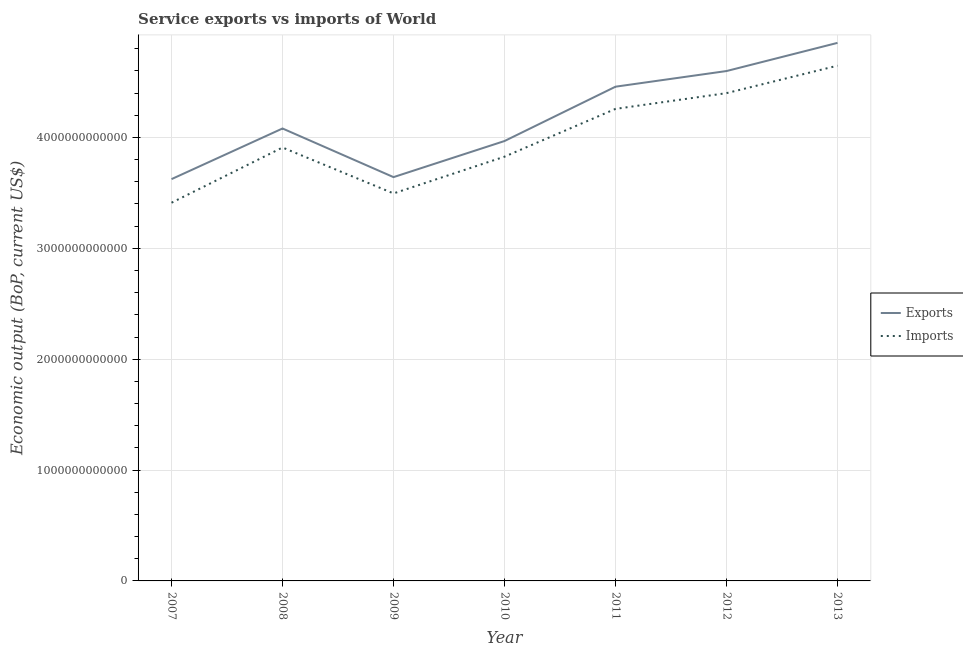How many different coloured lines are there?
Offer a terse response. 2. Does the line corresponding to amount of service imports intersect with the line corresponding to amount of service exports?
Your response must be concise. No. What is the amount of service exports in 2012?
Make the answer very short. 4.60e+12. Across all years, what is the maximum amount of service imports?
Make the answer very short. 4.65e+12. Across all years, what is the minimum amount of service imports?
Provide a short and direct response. 3.41e+12. What is the total amount of service imports in the graph?
Keep it short and to the point. 2.79e+13. What is the difference between the amount of service imports in 2011 and that in 2013?
Provide a succinct answer. -3.90e+11. What is the difference between the amount of service exports in 2011 and the amount of service imports in 2009?
Your answer should be very brief. 9.63e+11. What is the average amount of service exports per year?
Your answer should be compact. 4.18e+12. In the year 2013, what is the difference between the amount of service exports and amount of service imports?
Make the answer very short. 2.06e+11. In how many years, is the amount of service exports greater than 3000000000000 US$?
Offer a terse response. 7. What is the ratio of the amount of service imports in 2008 to that in 2013?
Offer a terse response. 0.84. Is the amount of service exports in 2007 less than that in 2009?
Offer a very short reply. Yes. Is the difference between the amount of service imports in 2007 and 2013 greater than the difference between the amount of service exports in 2007 and 2013?
Offer a very short reply. No. What is the difference between the highest and the second highest amount of service exports?
Give a very brief answer. 2.54e+11. What is the difference between the highest and the lowest amount of service imports?
Give a very brief answer. 1.24e+12. In how many years, is the amount of service imports greater than the average amount of service imports taken over all years?
Give a very brief answer. 3. Does the amount of service exports monotonically increase over the years?
Offer a terse response. No. Is the amount of service imports strictly less than the amount of service exports over the years?
Offer a very short reply. Yes. How many lines are there?
Ensure brevity in your answer.  2. What is the difference between two consecutive major ticks on the Y-axis?
Provide a short and direct response. 1.00e+12. Are the values on the major ticks of Y-axis written in scientific E-notation?
Your response must be concise. No. Does the graph contain grids?
Offer a terse response. Yes. How many legend labels are there?
Keep it short and to the point. 2. How are the legend labels stacked?
Provide a short and direct response. Vertical. What is the title of the graph?
Offer a terse response. Service exports vs imports of World. What is the label or title of the Y-axis?
Keep it short and to the point. Economic output (BoP, current US$). What is the Economic output (BoP, current US$) of Exports in 2007?
Offer a terse response. 3.62e+12. What is the Economic output (BoP, current US$) of Imports in 2007?
Offer a terse response. 3.41e+12. What is the Economic output (BoP, current US$) of Exports in 2008?
Your answer should be very brief. 4.08e+12. What is the Economic output (BoP, current US$) in Imports in 2008?
Your answer should be very brief. 3.91e+12. What is the Economic output (BoP, current US$) of Exports in 2009?
Ensure brevity in your answer.  3.64e+12. What is the Economic output (BoP, current US$) in Imports in 2009?
Your response must be concise. 3.50e+12. What is the Economic output (BoP, current US$) of Exports in 2010?
Make the answer very short. 3.97e+12. What is the Economic output (BoP, current US$) of Imports in 2010?
Your answer should be compact. 3.83e+12. What is the Economic output (BoP, current US$) of Exports in 2011?
Ensure brevity in your answer.  4.46e+12. What is the Economic output (BoP, current US$) in Imports in 2011?
Offer a very short reply. 4.26e+12. What is the Economic output (BoP, current US$) in Exports in 2012?
Your answer should be compact. 4.60e+12. What is the Economic output (BoP, current US$) of Imports in 2012?
Make the answer very short. 4.40e+12. What is the Economic output (BoP, current US$) in Exports in 2013?
Offer a terse response. 4.85e+12. What is the Economic output (BoP, current US$) of Imports in 2013?
Your response must be concise. 4.65e+12. Across all years, what is the maximum Economic output (BoP, current US$) in Exports?
Offer a very short reply. 4.85e+12. Across all years, what is the maximum Economic output (BoP, current US$) in Imports?
Keep it short and to the point. 4.65e+12. Across all years, what is the minimum Economic output (BoP, current US$) of Exports?
Give a very brief answer. 3.62e+12. Across all years, what is the minimum Economic output (BoP, current US$) of Imports?
Make the answer very short. 3.41e+12. What is the total Economic output (BoP, current US$) of Exports in the graph?
Ensure brevity in your answer.  2.92e+13. What is the total Economic output (BoP, current US$) in Imports in the graph?
Ensure brevity in your answer.  2.79e+13. What is the difference between the Economic output (BoP, current US$) of Exports in 2007 and that in 2008?
Ensure brevity in your answer.  -4.57e+11. What is the difference between the Economic output (BoP, current US$) in Imports in 2007 and that in 2008?
Keep it short and to the point. -4.98e+11. What is the difference between the Economic output (BoP, current US$) of Exports in 2007 and that in 2009?
Your answer should be very brief. -1.81e+1. What is the difference between the Economic output (BoP, current US$) in Imports in 2007 and that in 2009?
Provide a short and direct response. -8.39e+1. What is the difference between the Economic output (BoP, current US$) of Exports in 2007 and that in 2010?
Your answer should be very brief. -3.44e+11. What is the difference between the Economic output (BoP, current US$) of Imports in 2007 and that in 2010?
Your answer should be compact. -4.15e+11. What is the difference between the Economic output (BoP, current US$) of Exports in 2007 and that in 2011?
Give a very brief answer. -8.34e+11. What is the difference between the Economic output (BoP, current US$) in Imports in 2007 and that in 2011?
Provide a succinct answer. -8.47e+11. What is the difference between the Economic output (BoP, current US$) of Exports in 2007 and that in 2012?
Keep it short and to the point. -9.75e+11. What is the difference between the Economic output (BoP, current US$) of Imports in 2007 and that in 2012?
Keep it short and to the point. -9.89e+11. What is the difference between the Economic output (BoP, current US$) of Exports in 2007 and that in 2013?
Provide a succinct answer. -1.23e+12. What is the difference between the Economic output (BoP, current US$) of Imports in 2007 and that in 2013?
Provide a succinct answer. -1.24e+12. What is the difference between the Economic output (BoP, current US$) in Exports in 2008 and that in 2009?
Your response must be concise. 4.39e+11. What is the difference between the Economic output (BoP, current US$) in Imports in 2008 and that in 2009?
Make the answer very short. 4.14e+11. What is the difference between the Economic output (BoP, current US$) in Exports in 2008 and that in 2010?
Your answer should be compact. 1.13e+11. What is the difference between the Economic output (BoP, current US$) in Imports in 2008 and that in 2010?
Give a very brief answer. 8.29e+1. What is the difference between the Economic output (BoP, current US$) in Exports in 2008 and that in 2011?
Offer a very short reply. -3.77e+11. What is the difference between the Economic output (BoP, current US$) of Imports in 2008 and that in 2011?
Provide a short and direct response. -3.48e+11. What is the difference between the Economic output (BoP, current US$) of Exports in 2008 and that in 2012?
Offer a very short reply. -5.18e+11. What is the difference between the Economic output (BoP, current US$) of Imports in 2008 and that in 2012?
Your answer should be very brief. -4.90e+11. What is the difference between the Economic output (BoP, current US$) of Exports in 2008 and that in 2013?
Ensure brevity in your answer.  -7.72e+11. What is the difference between the Economic output (BoP, current US$) in Imports in 2008 and that in 2013?
Provide a short and direct response. -7.38e+11. What is the difference between the Economic output (BoP, current US$) of Exports in 2009 and that in 2010?
Ensure brevity in your answer.  -3.26e+11. What is the difference between the Economic output (BoP, current US$) of Imports in 2009 and that in 2010?
Make the answer very short. -3.31e+11. What is the difference between the Economic output (BoP, current US$) in Exports in 2009 and that in 2011?
Ensure brevity in your answer.  -8.16e+11. What is the difference between the Economic output (BoP, current US$) in Imports in 2009 and that in 2011?
Make the answer very short. -7.63e+11. What is the difference between the Economic output (BoP, current US$) in Exports in 2009 and that in 2012?
Your response must be concise. -9.57e+11. What is the difference between the Economic output (BoP, current US$) of Imports in 2009 and that in 2012?
Offer a very short reply. -9.05e+11. What is the difference between the Economic output (BoP, current US$) in Exports in 2009 and that in 2013?
Your answer should be compact. -1.21e+12. What is the difference between the Economic output (BoP, current US$) of Imports in 2009 and that in 2013?
Keep it short and to the point. -1.15e+12. What is the difference between the Economic output (BoP, current US$) in Exports in 2010 and that in 2011?
Your answer should be compact. -4.90e+11. What is the difference between the Economic output (BoP, current US$) in Imports in 2010 and that in 2011?
Provide a short and direct response. -4.31e+11. What is the difference between the Economic output (BoP, current US$) in Exports in 2010 and that in 2012?
Provide a short and direct response. -6.31e+11. What is the difference between the Economic output (BoP, current US$) of Imports in 2010 and that in 2012?
Provide a short and direct response. -5.73e+11. What is the difference between the Economic output (BoP, current US$) of Exports in 2010 and that in 2013?
Provide a short and direct response. -8.85e+11. What is the difference between the Economic output (BoP, current US$) of Imports in 2010 and that in 2013?
Offer a very short reply. -8.21e+11. What is the difference between the Economic output (BoP, current US$) in Exports in 2011 and that in 2012?
Your answer should be very brief. -1.41e+11. What is the difference between the Economic output (BoP, current US$) of Imports in 2011 and that in 2012?
Provide a short and direct response. -1.42e+11. What is the difference between the Economic output (BoP, current US$) in Exports in 2011 and that in 2013?
Make the answer very short. -3.95e+11. What is the difference between the Economic output (BoP, current US$) of Imports in 2011 and that in 2013?
Give a very brief answer. -3.90e+11. What is the difference between the Economic output (BoP, current US$) in Exports in 2012 and that in 2013?
Your response must be concise. -2.54e+11. What is the difference between the Economic output (BoP, current US$) of Imports in 2012 and that in 2013?
Provide a succinct answer. -2.48e+11. What is the difference between the Economic output (BoP, current US$) of Exports in 2007 and the Economic output (BoP, current US$) of Imports in 2008?
Keep it short and to the point. -2.85e+11. What is the difference between the Economic output (BoP, current US$) of Exports in 2007 and the Economic output (BoP, current US$) of Imports in 2009?
Offer a terse response. 1.29e+11. What is the difference between the Economic output (BoP, current US$) in Exports in 2007 and the Economic output (BoP, current US$) in Imports in 2010?
Offer a very short reply. -2.02e+11. What is the difference between the Economic output (BoP, current US$) in Exports in 2007 and the Economic output (BoP, current US$) in Imports in 2011?
Provide a short and direct response. -6.34e+11. What is the difference between the Economic output (BoP, current US$) in Exports in 2007 and the Economic output (BoP, current US$) in Imports in 2012?
Your response must be concise. -7.76e+11. What is the difference between the Economic output (BoP, current US$) in Exports in 2007 and the Economic output (BoP, current US$) in Imports in 2013?
Give a very brief answer. -1.02e+12. What is the difference between the Economic output (BoP, current US$) in Exports in 2008 and the Economic output (BoP, current US$) in Imports in 2009?
Give a very brief answer. 5.86e+11. What is the difference between the Economic output (BoP, current US$) in Exports in 2008 and the Economic output (BoP, current US$) in Imports in 2010?
Offer a very short reply. 2.54e+11. What is the difference between the Economic output (BoP, current US$) in Exports in 2008 and the Economic output (BoP, current US$) in Imports in 2011?
Provide a succinct answer. -1.77e+11. What is the difference between the Economic output (BoP, current US$) in Exports in 2008 and the Economic output (BoP, current US$) in Imports in 2012?
Offer a very short reply. -3.19e+11. What is the difference between the Economic output (BoP, current US$) of Exports in 2008 and the Economic output (BoP, current US$) of Imports in 2013?
Provide a succinct answer. -5.67e+11. What is the difference between the Economic output (BoP, current US$) of Exports in 2009 and the Economic output (BoP, current US$) of Imports in 2010?
Keep it short and to the point. -1.84e+11. What is the difference between the Economic output (BoP, current US$) in Exports in 2009 and the Economic output (BoP, current US$) in Imports in 2011?
Your answer should be very brief. -6.16e+11. What is the difference between the Economic output (BoP, current US$) in Exports in 2009 and the Economic output (BoP, current US$) in Imports in 2012?
Keep it short and to the point. -7.58e+11. What is the difference between the Economic output (BoP, current US$) of Exports in 2009 and the Economic output (BoP, current US$) of Imports in 2013?
Your response must be concise. -1.01e+12. What is the difference between the Economic output (BoP, current US$) of Exports in 2010 and the Economic output (BoP, current US$) of Imports in 2011?
Provide a succinct answer. -2.90e+11. What is the difference between the Economic output (BoP, current US$) in Exports in 2010 and the Economic output (BoP, current US$) in Imports in 2012?
Offer a terse response. -4.32e+11. What is the difference between the Economic output (BoP, current US$) of Exports in 2010 and the Economic output (BoP, current US$) of Imports in 2013?
Provide a succinct answer. -6.80e+11. What is the difference between the Economic output (BoP, current US$) in Exports in 2011 and the Economic output (BoP, current US$) in Imports in 2012?
Your response must be concise. 5.81e+1. What is the difference between the Economic output (BoP, current US$) in Exports in 2011 and the Economic output (BoP, current US$) in Imports in 2013?
Keep it short and to the point. -1.89e+11. What is the difference between the Economic output (BoP, current US$) in Exports in 2012 and the Economic output (BoP, current US$) in Imports in 2013?
Provide a succinct answer. -4.83e+1. What is the average Economic output (BoP, current US$) of Exports per year?
Give a very brief answer. 4.18e+12. What is the average Economic output (BoP, current US$) of Imports per year?
Offer a very short reply. 3.99e+12. In the year 2007, what is the difference between the Economic output (BoP, current US$) of Exports and Economic output (BoP, current US$) of Imports?
Keep it short and to the point. 2.13e+11. In the year 2008, what is the difference between the Economic output (BoP, current US$) of Exports and Economic output (BoP, current US$) of Imports?
Give a very brief answer. 1.72e+11. In the year 2009, what is the difference between the Economic output (BoP, current US$) of Exports and Economic output (BoP, current US$) of Imports?
Your answer should be compact. 1.47e+11. In the year 2010, what is the difference between the Economic output (BoP, current US$) of Exports and Economic output (BoP, current US$) of Imports?
Your answer should be compact. 1.41e+11. In the year 2011, what is the difference between the Economic output (BoP, current US$) of Exports and Economic output (BoP, current US$) of Imports?
Your answer should be compact. 2.00e+11. In the year 2012, what is the difference between the Economic output (BoP, current US$) in Exports and Economic output (BoP, current US$) in Imports?
Ensure brevity in your answer.  1.99e+11. In the year 2013, what is the difference between the Economic output (BoP, current US$) of Exports and Economic output (BoP, current US$) of Imports?
Make the answer very short. 2.06e+11. What is the ratio of the Economic output (BoP, current US$) in Exports in 2007 to that in 2008?
Provide a succinct answer. 0.89. What is the ratio of the Economic output (BoP, current US$) of Imports in 2007 to that in 2008?
Offer a very short reply. 0.87. What is the ratio of the Economic output (BoP, current US$) of Exports in 2007 to that in 2010?
Your answer should be compact. 0.91. What is the ratio of the Economic output (BoP, current US$) in Imports in 2007 to that in 2010?
Your answer should be compact. 0.89. What is the ratio of the Economic output (BoP, current US$) in Exports in 2007 to that in 2011?
Your answer should be very brief. 0.81. What is the ratio of the Economic output (BoP, current US$) of Imports in 2007 to that in 2011?
Your answer should be compact. 0.8. What is the ratio of the Economic output (BoP, current US$) of Exports in 2007 to that in 2012?
Your answer should be very brief. 0.79. What is the ratio of the Economic output (BoP, current US$) of Imports in 2007 to that in 2012?
Offer a very short reply. 0.78. What is the ratio of the Economic output (BoP, current US$) in Exports in 2007 to that in 2013?
Provide a succinct answer. 0.75. What is the ratio of the Economic output (BoP, current US$) in Imports in 2007 to that in 2013?
Provide a succinct answer. 0.73. What is the ratio of the Economic output (BoP, current US$) of Exports in 2008 to that in 2009?
Ensure brevity in your answer.  1.12. What is the ratio of the Economic output (BoP, current US$) of Imports in 2008 to that in 2009?
Offer a very short reply. 1.12. What is the ratio of the Economic output (BoP, current US$) in Exports in 2008 to that in 2010?
Ensure brevity in your answer.  1.03. What is the ratio of the Economic output (BoP, current US$) in Imports in 2008 to that in 2010?
Keep it short and to the point. 1.02. What is the ratio of the Economic output (BoP, current US$) in Exports in 2008 to that in 2011?
Keep it short and to the point. 0.92. What is the ratio of the Economic output (BoP, current US$) of Imports in 2008 to that in 2011?
Your answer should be compact. 0.92. What is the ratio of the Economic output (BoP, current US$) in Exports in 2008 to that in 2012?
Provide a succinct answer. 0.89. What is the ratio of the Economic output (BoP, current US$) of Imports in 2008 to that in 2012?
Give a very brief answer. 0.89. What is the ratio of the Economic output (BoP, current US$) in Exports in 2008 to that in 2013?
Provide a succinct answer. 0.84. What is the ratio of the Economic output (BoP, current US$) in Imports in 2008 to that in 2013?
Provide a short and direct response. 0.84. What is the ratio of the Economic output (BoP, current US$) of Exports in 2009 to that in 2010?
Your answer should be very brief. 0.92. What is the ratio of the Economic output (BoP, current US$) of Imports in 2009 to that in 2010?
Your answer should be compact. 0.91. What is the ratio of the Economic output (BoP, current US$) of Exports in 2009 to that in 2011?
Your answer should be compact. 0.82. What is the ratio of the Economic output (BoP, current US$) in Imports in 2009 to that in 2011?
Offer a very short reply. 0.82. What is the ratio of the Economic output (BoP, current US$) of Exports in 2009 to that in 2012?
Keep it short and to the point. 0.79. What is the ratio of the Economic output (BoP, current US$) of Imports in 2009 to that in 2012?
Make the answer very short. 0.79. What is the ratio of the Economic output (BoP, current US$) of Exports in 2009 to that in 2013?
Your answer should be very brief. 0.75. What is the ratio of the Economic output (BoP, current US$) of Imports in 2009 to that in 2013?
Keep it short and to the point. 0.75. What is the ratio of the Economic output (BoP, current US$) in Exports in 2010 to that in 2011?
Your response must be concise. 0.89. What is the ratio of the Economic output (BoP, current US$) of Imports in 2010 to that in 2011?
Give a very brief answer. 0.9. What is the ratio of the Economic output (BoP, current US$) in Exports in 2010 to that in 2012?
Ensure brevity in your answer.  0.86. What is the ratio of the Economic output (BoP, current US$) in Imports in 2010 to that in 2012?
Provide a short and direct response. 0.87. What is the ratio of the Economic output (BoP, current US$) in Exports in 2010 to that in 2013?
Give a very brief answer. 0.82. What is the ratio of the Economic output (BoP, current US$) of Imports in 2010 to that in 2013?
Keep it short and to the point. 0.82. What is the ratio of the Economic output (BoP, current US$) in Exports in 2011 to that in 2012?
Your answer should be very brief. 0.97. What is the ratio of the Economic output (BoP, current US$) in Exports in 2011 to that in 2013?
Give a very brief answer. 0.92. What is the ratio of the Economic output (BoP, current US$) in Imports in 2011 to that in 2013?
Offer a terse response. 0.92. What is the ratio of the Economic output (BoP, current US$) in Exports in 2012 to that in 2013?
Ensure brevity in your answer.  0.95. What is the ratio of the Economic output (BoP, current US$) of Imports in 2012 to that in 2013?
Give a very brief answer. 0.95. What is the difference between the highest and the second highest Economic output (BoP, current US$) of Exports?
Ensure brevity in your answer.  2.54e+11. What is the difference between the highest and the second highest Economic output (BoP, current US$) of Imports?
Provide a succinct answer. 2.48e+11. What is the difference between the highest and the lowest Economic output (BoP, current US$) of Exports?
Keep it short and to the point. 1.23e+12. What is the difference between the highest and the lowest Economic output (BoP, current US$) of Imports?
Offer a terse response. 1.24e+12. 